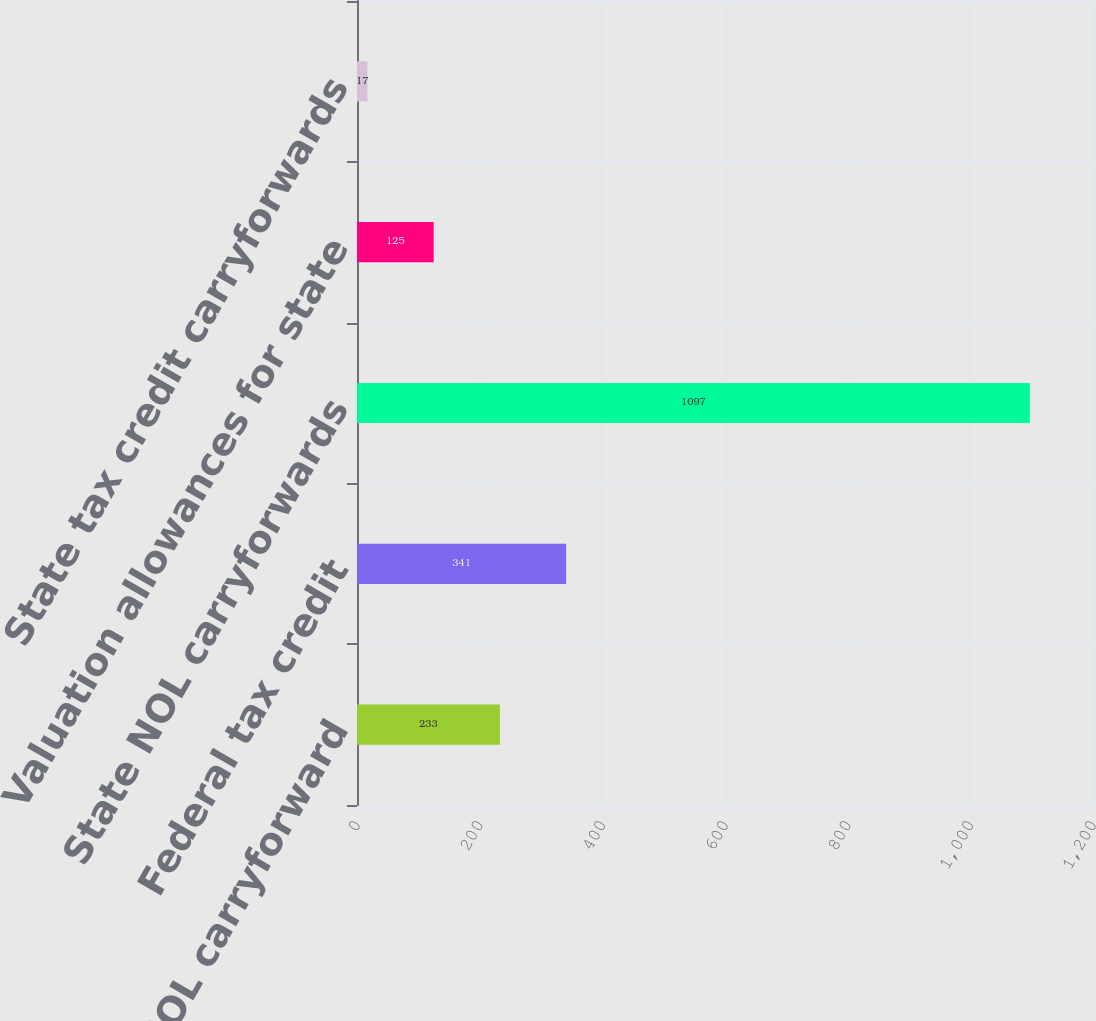Convert chart. <chart><loc_0><loc_0><loc_500><loc_500><bar_chart><fcel>Federal NOL carryforward<fcel>Federal tax credit<fcel>State NOL carryforwards<fcel>Valuation allowances for state<fcel>State tax credit carryforwards<nl><fcel>233<fcel>341<fcel>1097<fcel>125<fcel>17<nl></chart> 